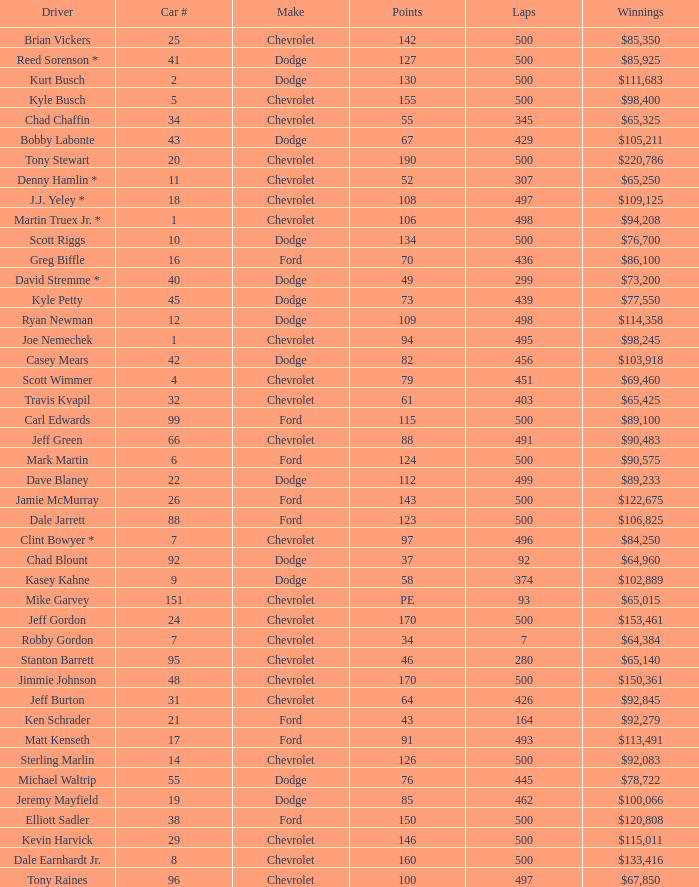What is the average car number of all the drivers who have won $111,683? 2.0. 